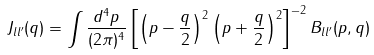<formula> <loc_0><loc_0><loc_500><loc_500>J _ { l l ^ { \prime } } ( q ) = \int \frac { d ^ { 4 } p } { ( 2 \pi ) ^ { 4 } } \left [ \left ( p - \frac { q } { 2 } \right ) ^ { 2 } \left ( p + \frac { q } { 2 } \right ) ^ { 2 } \right ] ^ { - 2 } B _ { l l ^ { \prime } } ( p , q )</formula> 